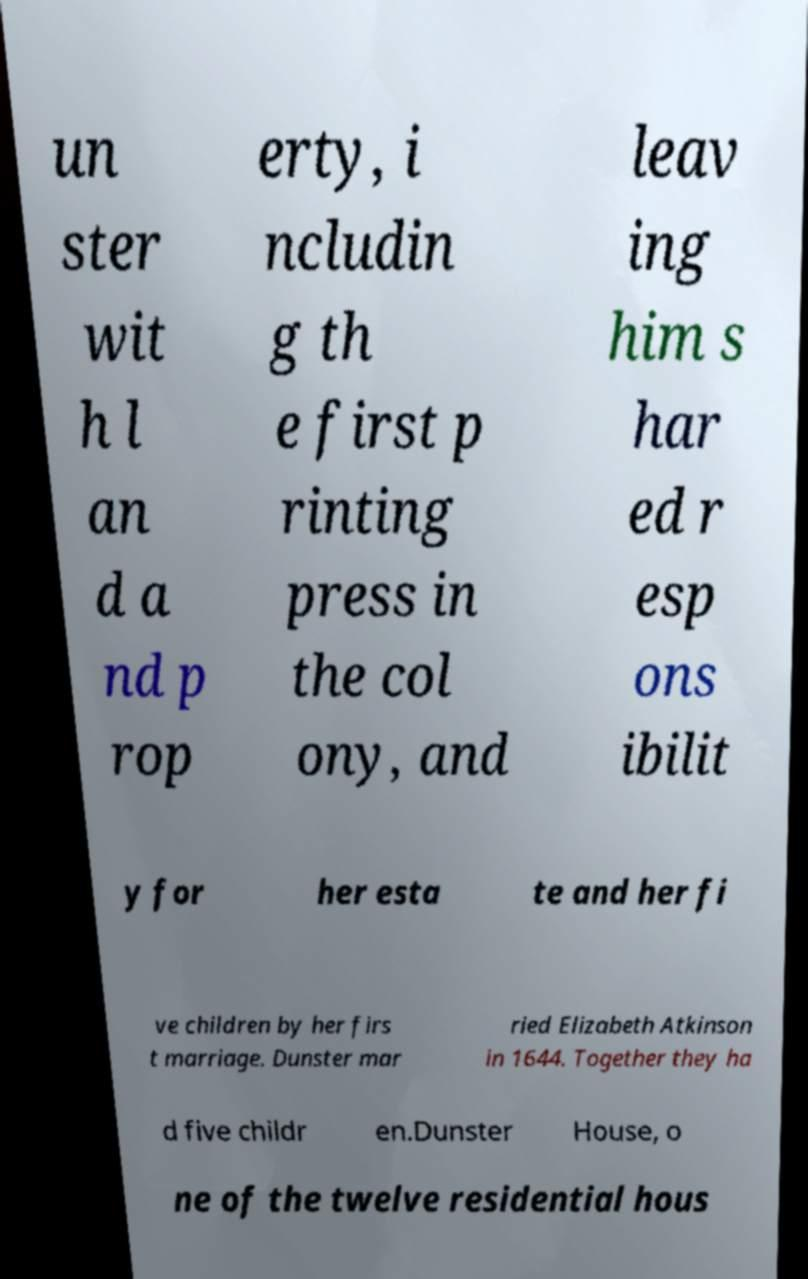For documentation purposes, I need the text within this image transcribed. Could you provide that? un ster wit h l an d a nd p rop erty, i ncludin g th e first p rinting press in the col ony, and leav ing him s har ed r esp ons ibilit y for her esta te and her fi ve children by her firs t marriage. Dunster mar ried Elizabeth Atkinson in 1644. Together they ha d five childr en.Dunster House, o ne of the twelve residential hous 